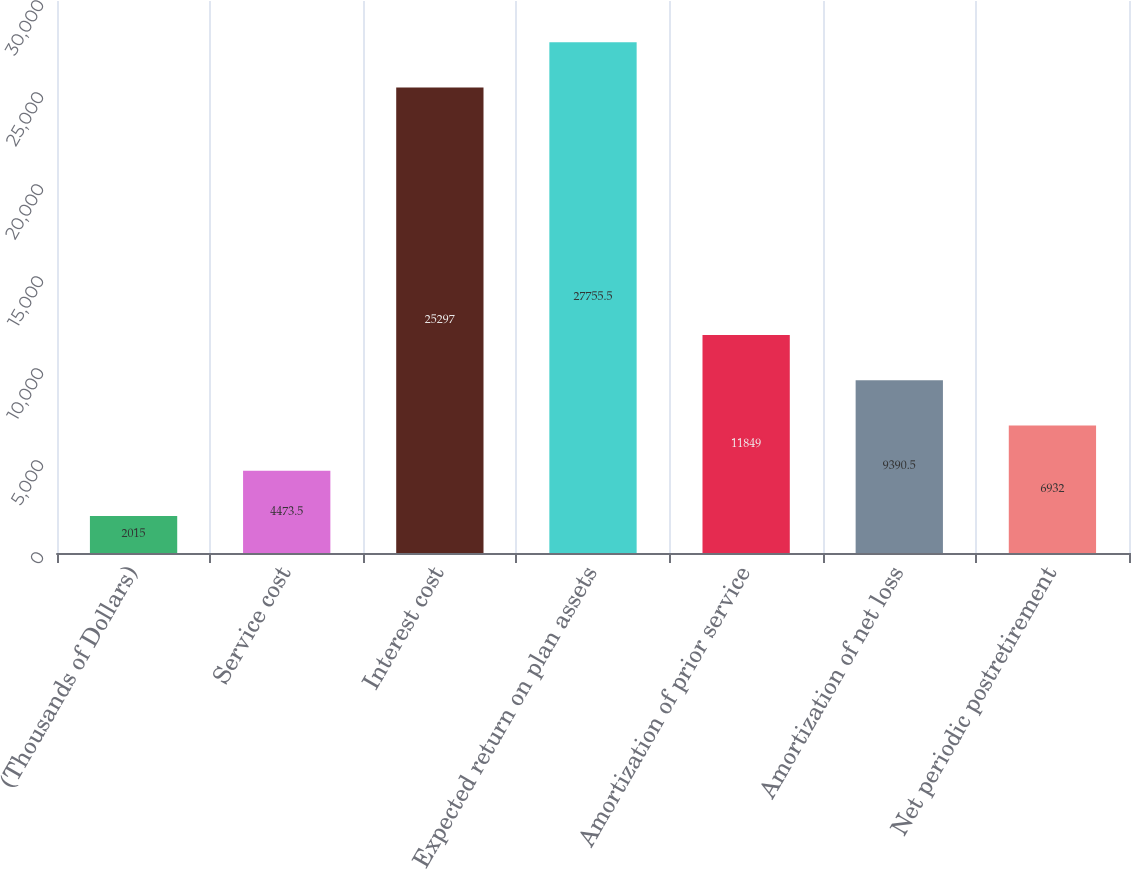Convert chart. <chart><loc_0><loc_0><loc_500><loc_500><bar_chart><fcel>(Thousands of Dollars)<fcel>Service cost<fcel>Interest cost<fcel>Expected return on plan assets<fcel>Amortization of prior service<fcel>Amortization of net loss<fcel>Net periodic postretirement<nl><fcel>2015<fcel>4473.5<fcel>25297<fcel>27755.5<fcel>11849<fcel>9390.5<fcel>6932<nl></chart> 